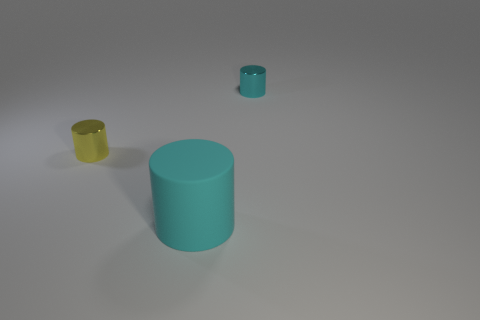There is another tiny cylinder that is the same color as the matte cylinder; what is its material?
Keep it short and to the point. Metal. What number of tiny gray metal objects have the same shape as the big cyan rubber thing?
Ensure brevity in your answer.  0. Are the small yellow thing and the thing that is behind the tiny yellow thing made of the same material?
Offer a terse response. Yes. What is the material of the yellow object that is the same size as the cyan shiny cylinder?
Provide a short and direct response. Metal. Is there another cyan shiny thing that has the same size as the cyan metal thing?
Your answer should be compact. No. What shape is the cyan thing that is the same size as the yellow cylinder?
Offer a terse response. Cylinder. There is a object that is both behind the big cyan cylinder and in front of the tiny cyan metal cylinder; what shape is it?
Provide a short and direct response. Cylinder. Are there any tiny cyan metal things that are on the left side of the metallic cylinder that is left of the cyan shiny object behind the large rubber object?
Ensure brevity in your answer.  No. How many other objects are there of the same material as the yellow cylinder?
Give a very brief answer. 1. How many things are either small blue rubber objects or metallic cylinders that are behind the yellow object?
Your answer should be very brief. 1. 